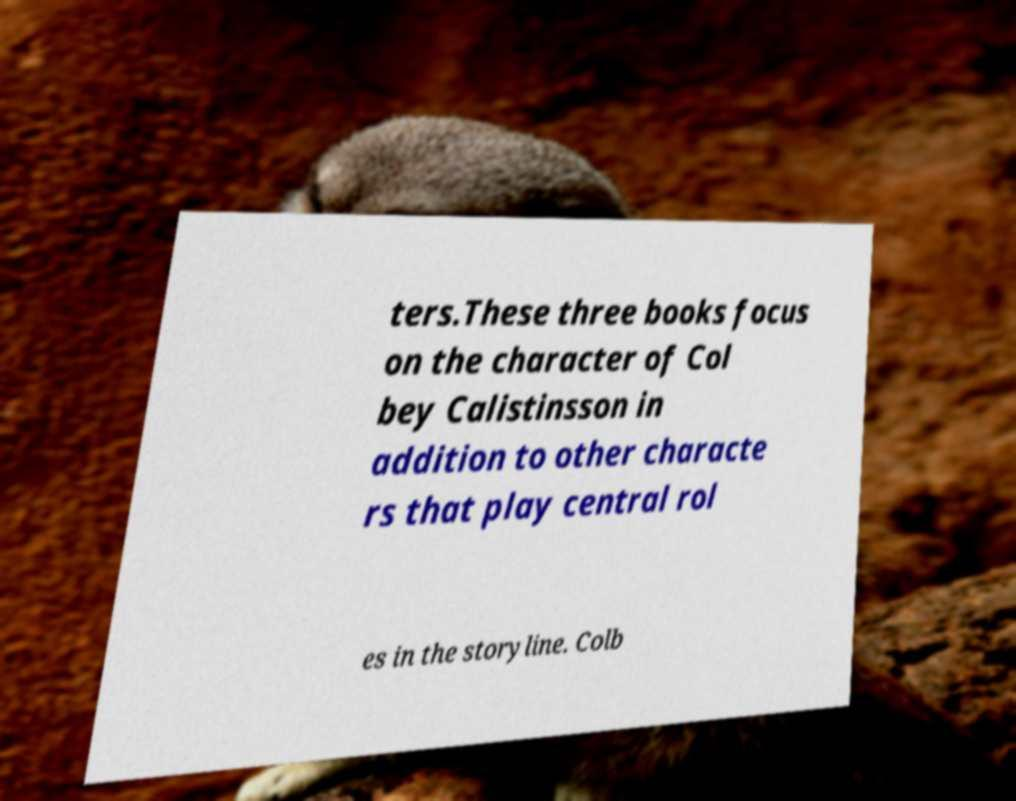Could you extract and type out the text from this image? ters.These three books focus on the character of Col bey Calistinsson in addition to other characte rs that play central rol es in the storyline. Colb 